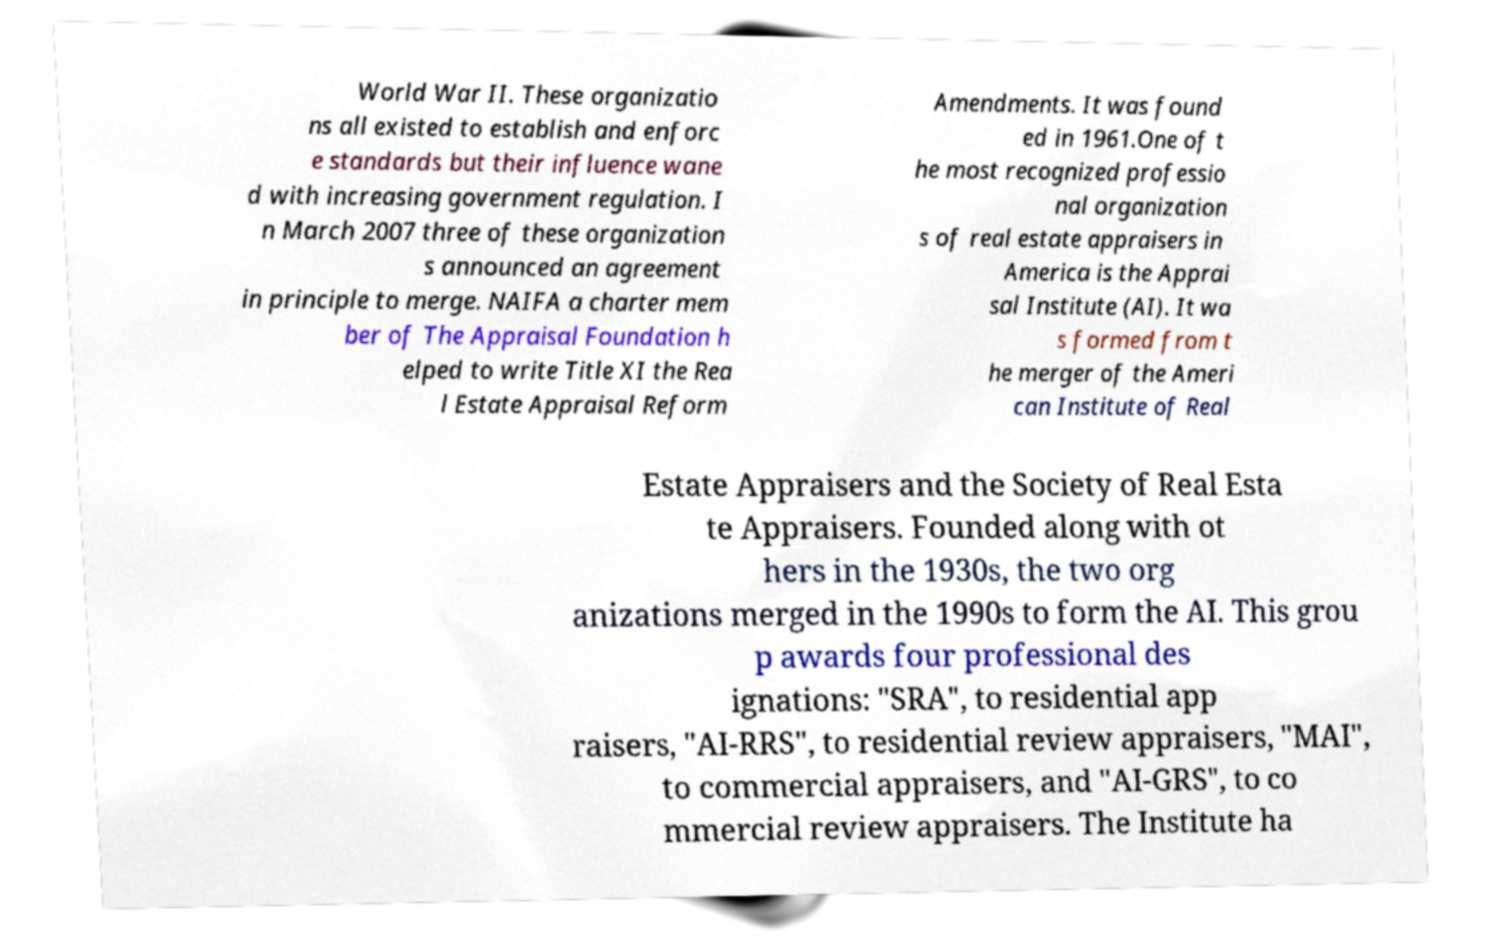For documentation purposes, I need the text within this image transcribed. Could you provide that? World War II. These organizatio ns all existed to establish and enforc e standards but their influence wane d with increasing government regulation. I n March 2007 three of these organization s announced an agreement in principle to merge. NAIFA a charter mem ber of The Appraisal Foundation h elped to write Title XI the Rea l Estate Appraisal Reform Amendments. It was found ed in 1961.One of t he most recognized professio nal organization s of real estate appraisers in America is the Apprai sal Institute (AI). It wa s formed from t he merger of the Ameri can Institute of Real Estate Appraisers and the Society of Real Esta te Appraisers. Founded along with ot hers in the 1930s, the two org anizations merged in the 1990s to form the AI. This grou p awards four professional des ignations: "SRA", to residential app raisers, "AI-RRS", to residential review appraisers, "MAI", to commercial appraisers, and "AI-GRS", to co mmercial review appraisers. The Institute ha 